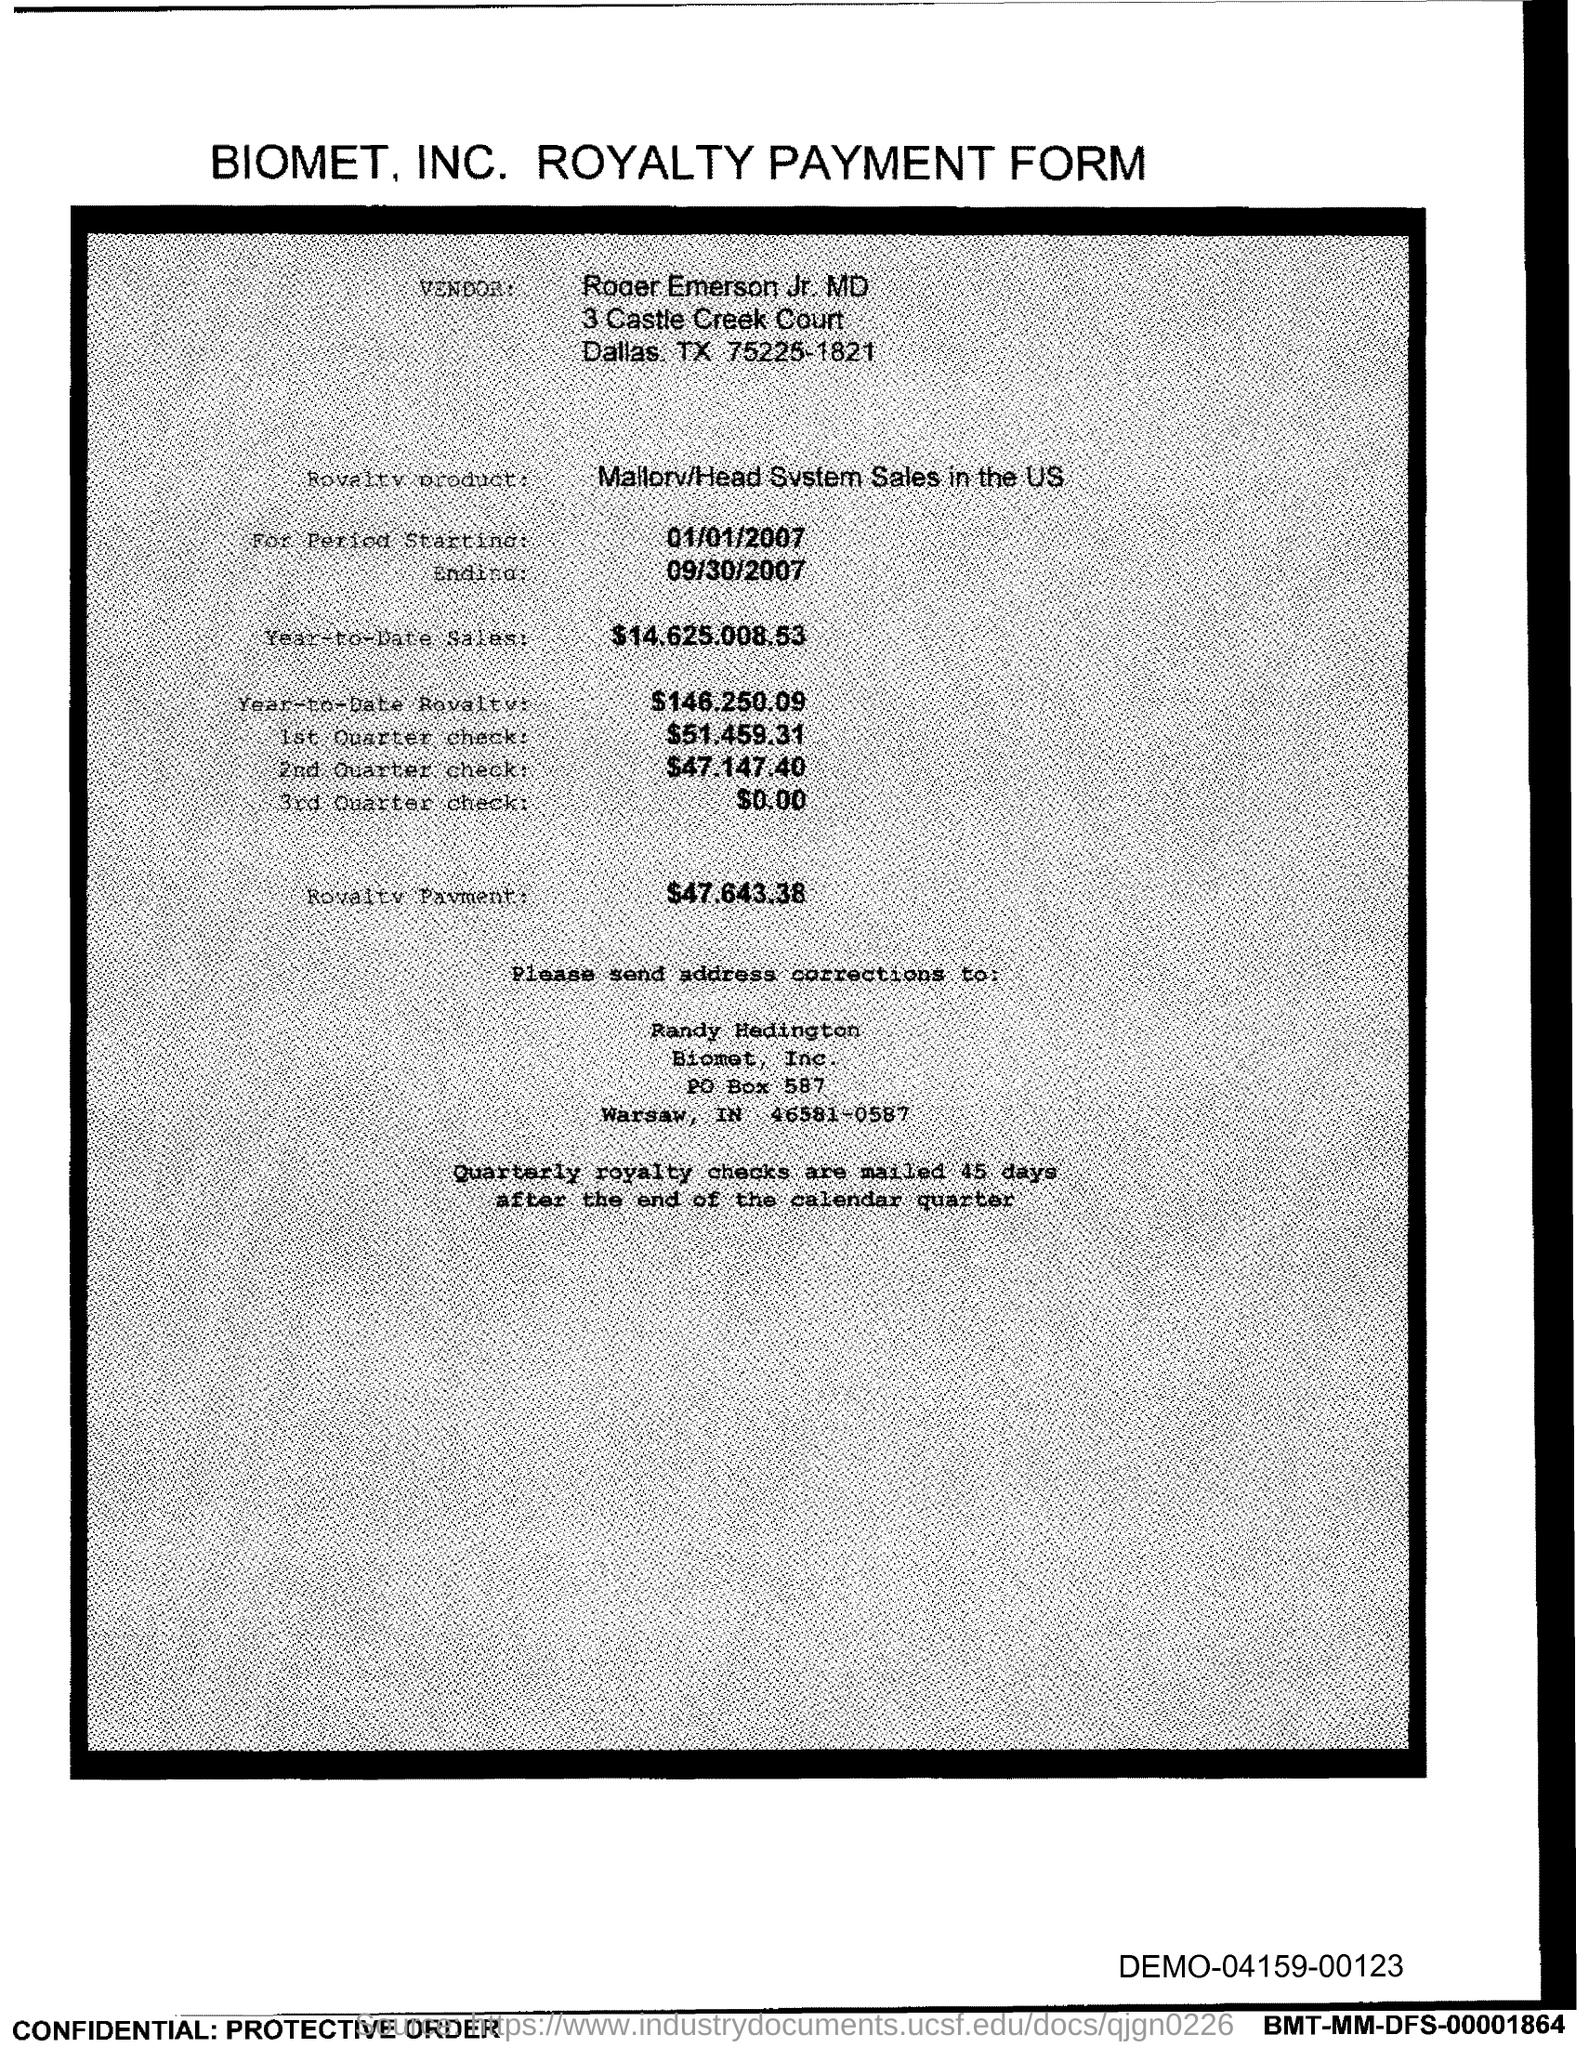What is the start date of the royalty period? The start date of the royalty period is January 1, 2007, as indicated on the Royalty Payment Form. 